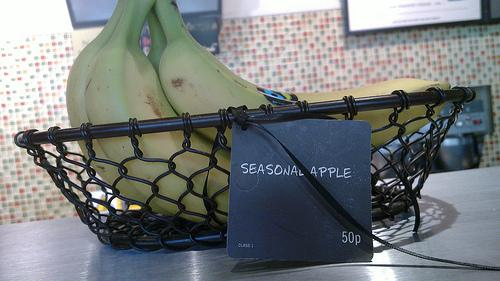Question: where is this scene?
Choices:
A. Bathroom.
B. Kitchen.
C. Basement.
D. Living room.
Answer with the letter. Answer: B Question: what fruits are there?
Choices:
A. Oranges.
B. Apples.
C. Bananas.
D. Grapes.
Answer with the letter. Answer: C Question: who is there?
Choices:
A. No one.
B. The neighbor.
C. The garbage man.
D. The Dr.
Answer with the letter. Answer: A Question: what type of scene?
Choices:
A. Outdoor.
B. Wedding.
C. Anniversary.
D. Indoor.
Answer with the letter. Answer: D Question: how is the photo?
Choices:
A. Clear.
B. Fuzzy.
C. Dark.
D. Too light to see.
Answer with the letter. Answer: A 